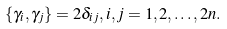Convert formula to latex. <formula><loc_0><loc_0><loc_500><loc_500>\{ \gamma _ { i } , \gamma _ { j } \} = 2 \delta _ { i j } , i , j = 1 , 2 , \dots , 2 n .</formula> 